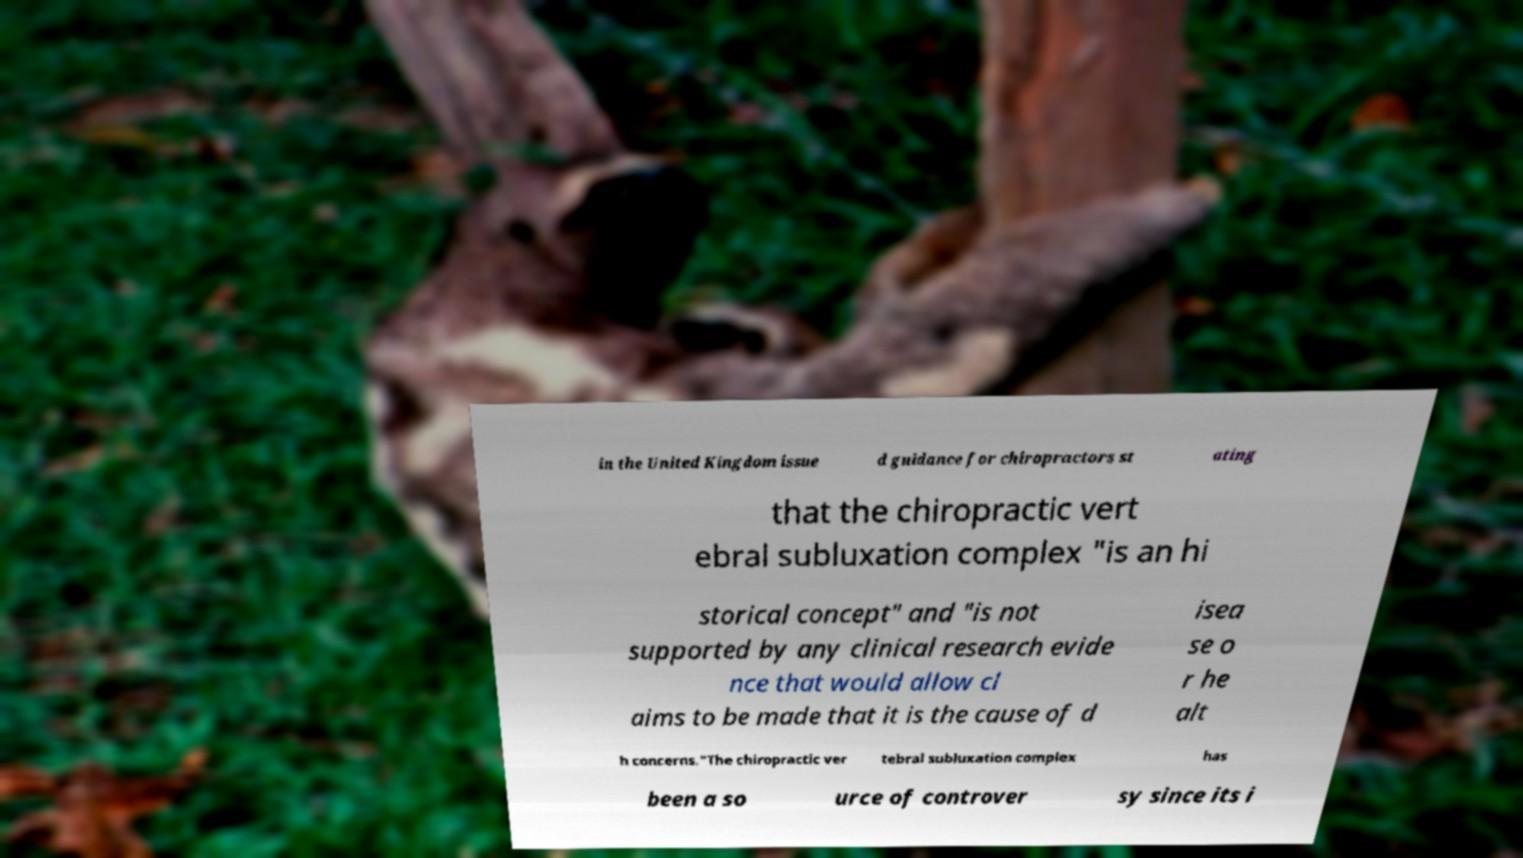I need the written content from this picture converted into text. Can you do that? in the United Kingdom issue d guidance for chiropractors st ating that the chiropractic vert ebral subluxation complex "is an hi storical concept" and "is not supported by any clinical research evide nce that would allow cl aims to be made that it is the cause of d isea se o r he alt h concerns."The chiropractic ver tebral subluxation complex has been a so urce of controver sy since its i 